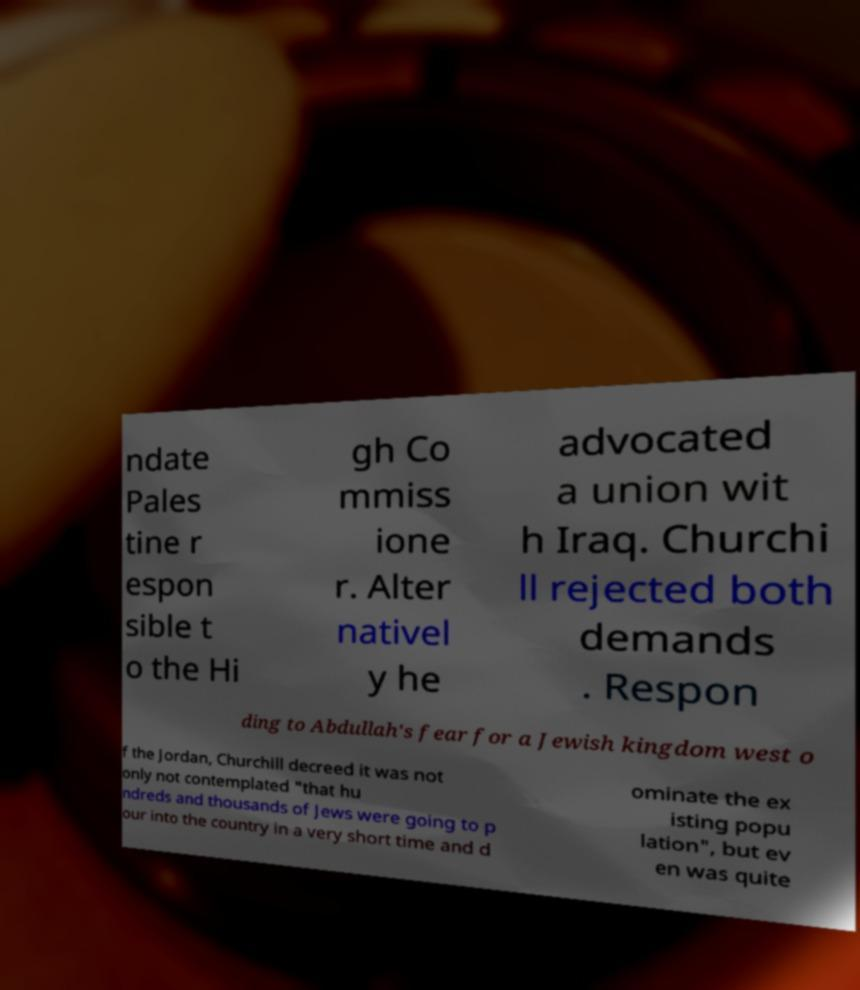I need the written content from this picture converted into text. Can you do that? ndate Pales tine r espon sible t o the Hi gh Co mmiss ione r. Alter nativel y he advocated a union wit h Iraq. Churchi ll rejected both demands . Respon ding to Abdullah's fear for a Jewish kingdom west o f the Jordan, Churchill decreed it was not only not contemplated "that hu ndreds and thousands of Jews were going to p our into the country in a very short time and d ominate the ex isting popu lation", but ev en was quite 